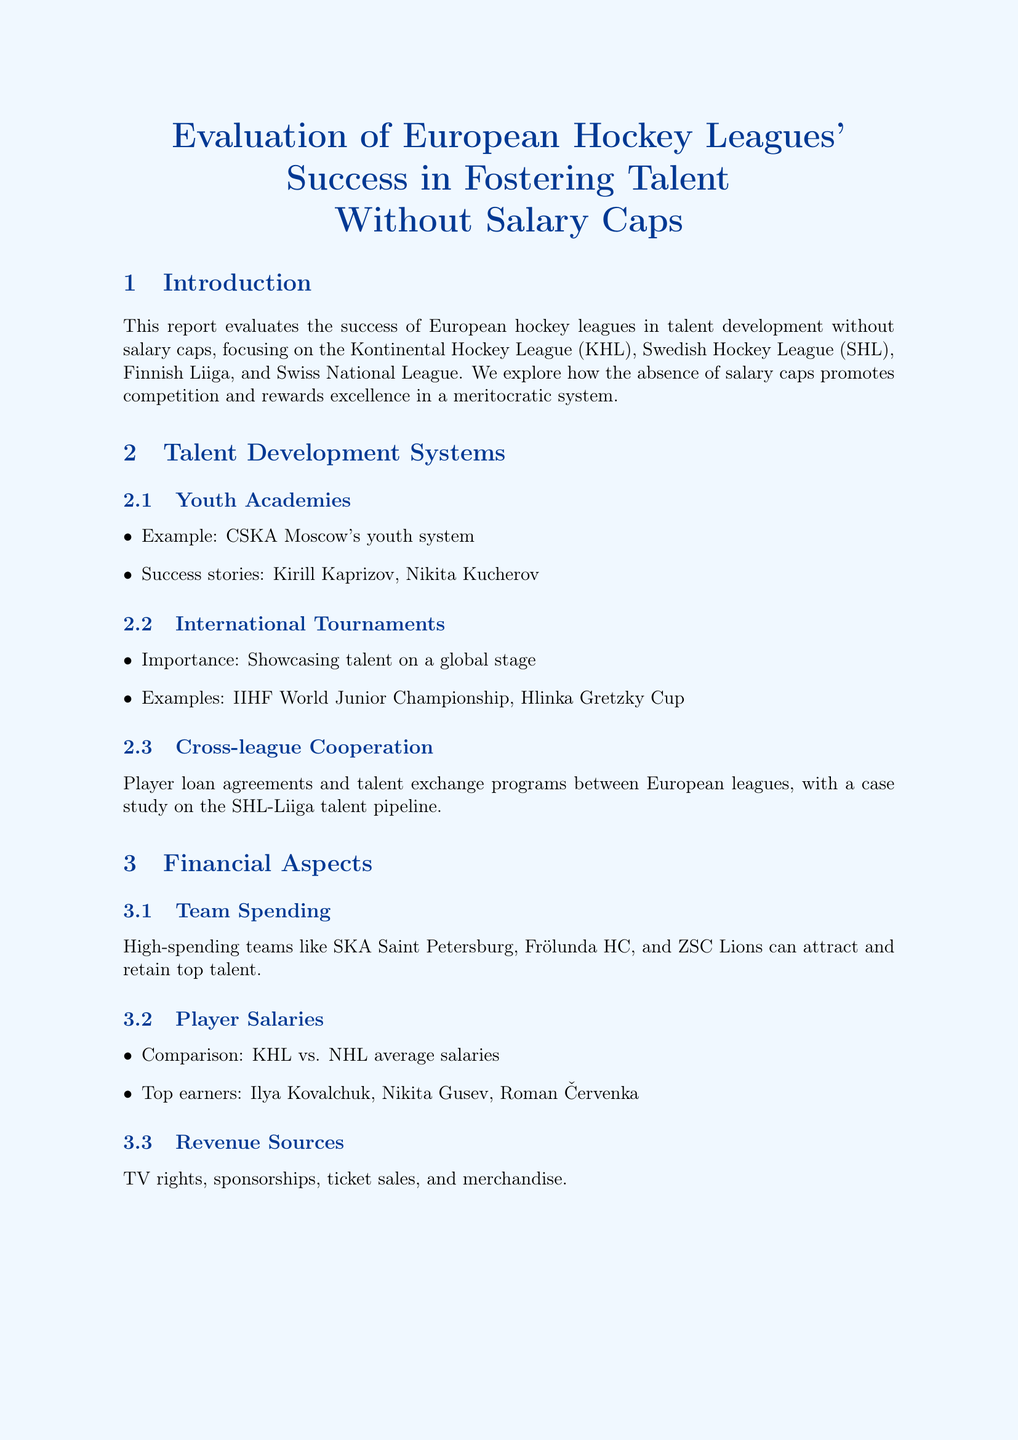What are the key leagues mentioned? The key leagues referred to in the document regarding talent development are specifically noted in the introduction section.
Answer: KHL, SHL, Liiga, Swiss National League Who is an example of a successful youth academy? A specific example of a prominent youth academy is provided in the talent development systems section.
Answer: CSKA Moscow What is a notable success story from the talent development systems? The document lists successful players as examples of effective youth academies.
Answer: Kirill Kaprizov What financial aspect allows teams to attract top talent? The analysis discusses team spending as a critical factor in talent acquisition within the financial aspects section.
Answer: High spending Which tournament showcases talent on a global stage? The importance of international tournaments for demonstrating talent is noted in the talent development systems section.
Answer: IIHF World Junior Championship What is a challenge mentioned regarding player movement? The document discusses specific issues faced by European leagues, particularly related to top players moving to another league.
Answer: Talent drain What factors contributed to Leksands IF's resurgence? The underdog stories section provides insights into the reasons behind the team's success.
Answer: Smart scouting, effective coaching, team chemistry What type of future market is identified as having potential growth? Emerging markets are described in a specific section forecasting future developments in European hockey.
Answer: China What is the conclusion about the success of European leagues? The conclusion summarizes the overall findings regarding the effectiveness of European leagues in talent development.
Answer: Success in talent development without salary caps 